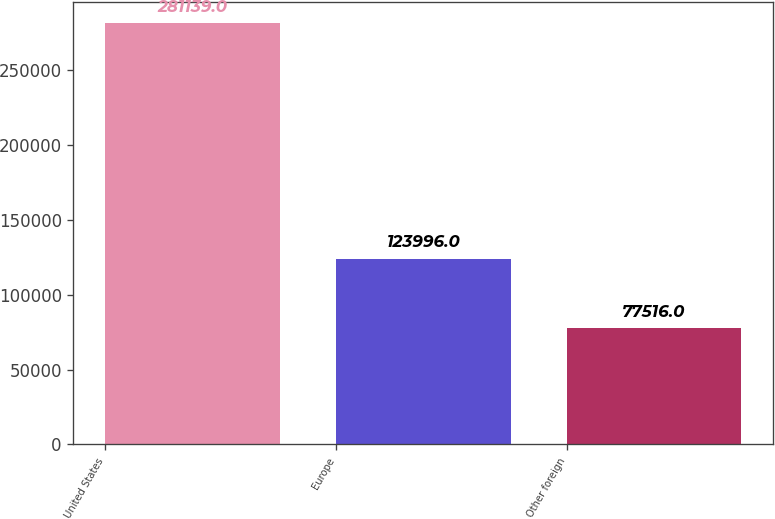<chart> <loc_0><loc_0><loc_500><loc_500><bar_chart><fcel>United States<fcel>Europe<fcel>Other foreign<nl><fcel>281139<fcel>123996<fcel>77516<nl></chart> 